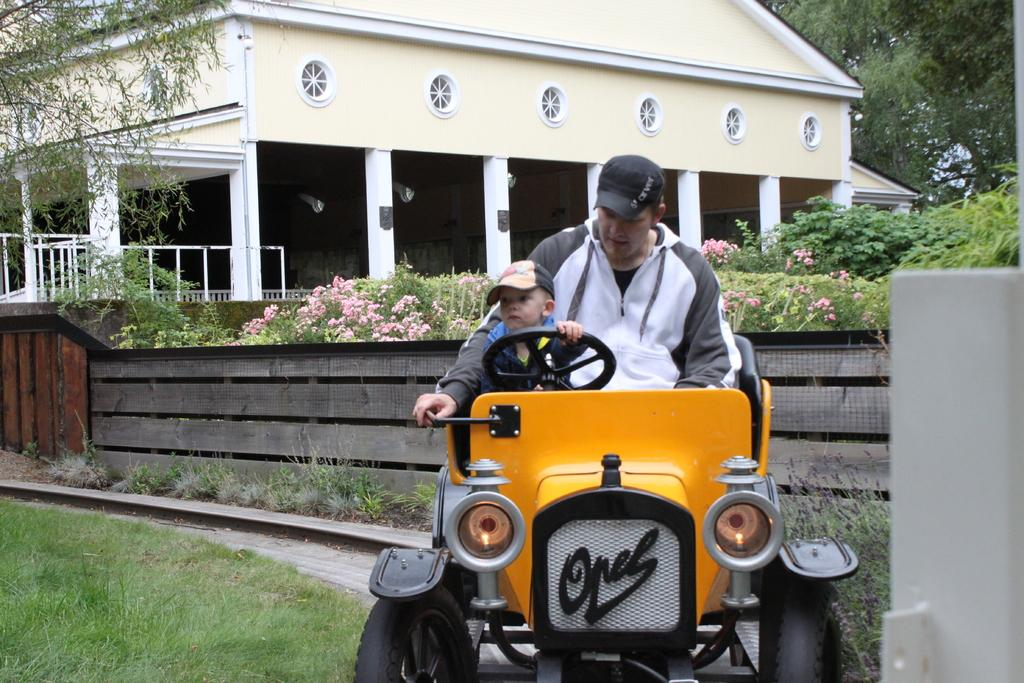Who is present in the image? There is a man and a boy in the image. What are they doing in the image? Both the man and the boy are sitting on a vehicle. What can be seen in the background of the image? There are trees in the background of the image. What type of vegetation is present in the image? There is grass and plants with flowers in the image. What structure is visible in the image? There is a house in the image. What material is present in the image? There are iron rods in the image. What type of parcel is being exchanged between the man and the boy in the image? There is no parcel being exchanged between the man and the boy in the image. What type of power source is visible in the image? There is no power source visible in the image. 